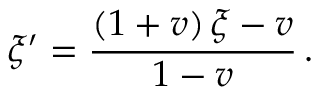<formula> <loc_0><loc_0><loc_500><loc_500>\xi ^ { \prime } = \frac { \left ( 1 + v \right ) \xi - v } { 1 - v } \, .</formula> 